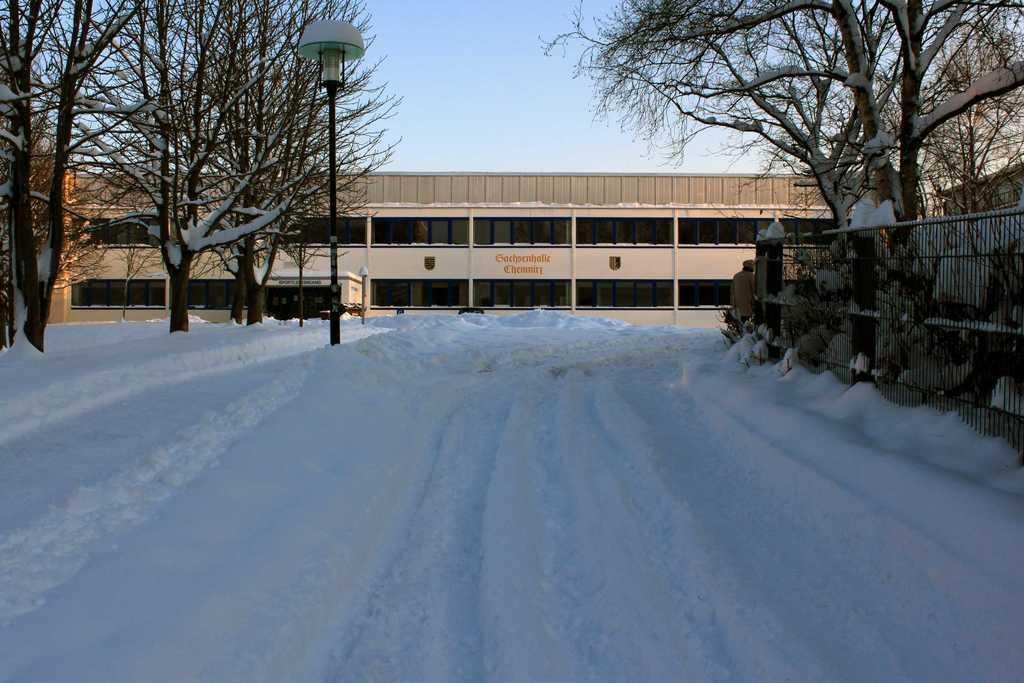How would you summarize this image in a sentence or two? In this image I can see the snow, the railing, few trees, a black colored pole and a building which is cream in color. In the background I can see the sky. 